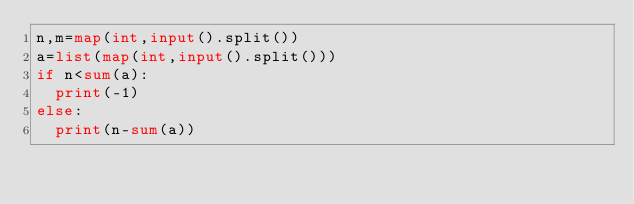<code> <loc_0><loc_0><loc_500><loc_500><_Python_>n,m=map(int,input().split())
a=list(map(int,input().split()))
if n<sum(a):
  print(-1)
else:
  print(n-sum(a))</code> 